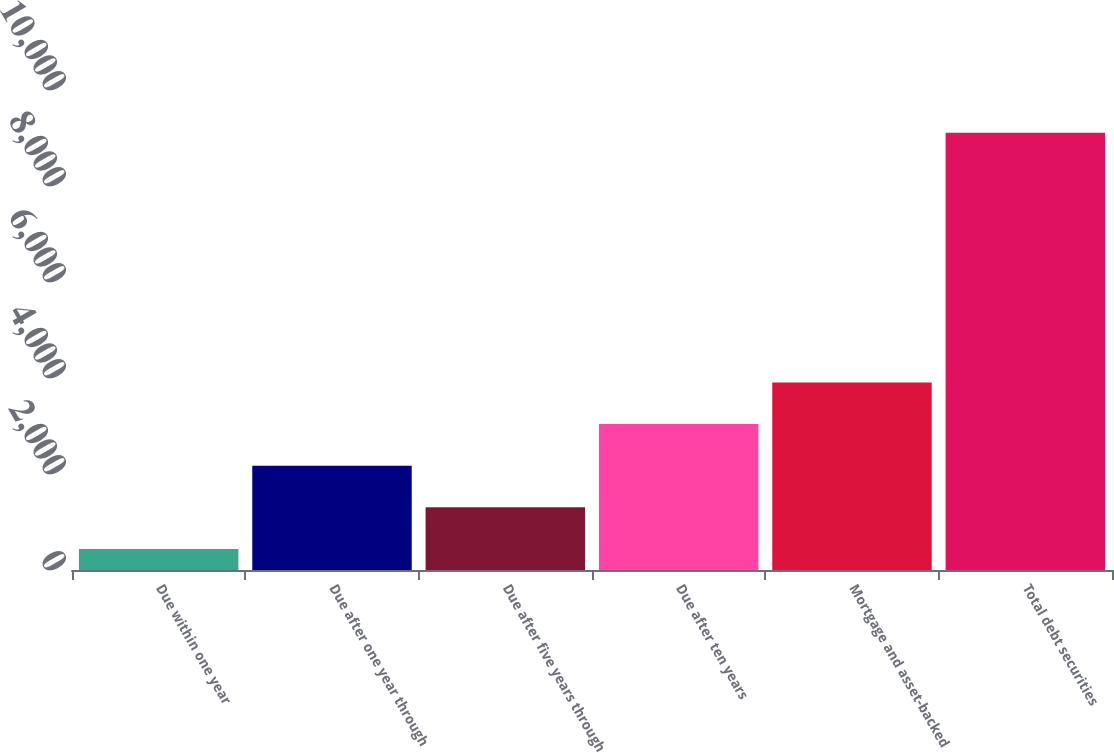<chart> <loc_0><loc_0><loc_500><loc_500><bar_chart><fcel>Due within one year<fcel>Due after one year through<fcel>Due after five years through<fcel>Due after ten years<fcel>Mortgage and asset-backed<fcel>Total debt securities<nl><fcel>439<fcel>2173.2<fcel>1306.1<fcel>3040.3<fcel>3907.4<fcel>9110<nl></chart> 